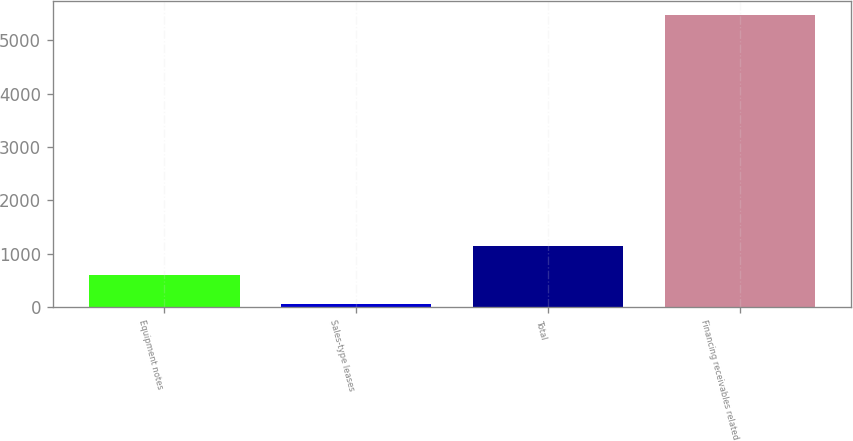<chart> <loc_0><loc_0><loc_500><loc_500><bar_chart><fcel>Equipment notes<fcel>Sales-type leases<fcel>Total<fcel>Financing receivables related<nl><fcel>604<fcel>64<fcel>1144<fcel>5464<nl></chart> 